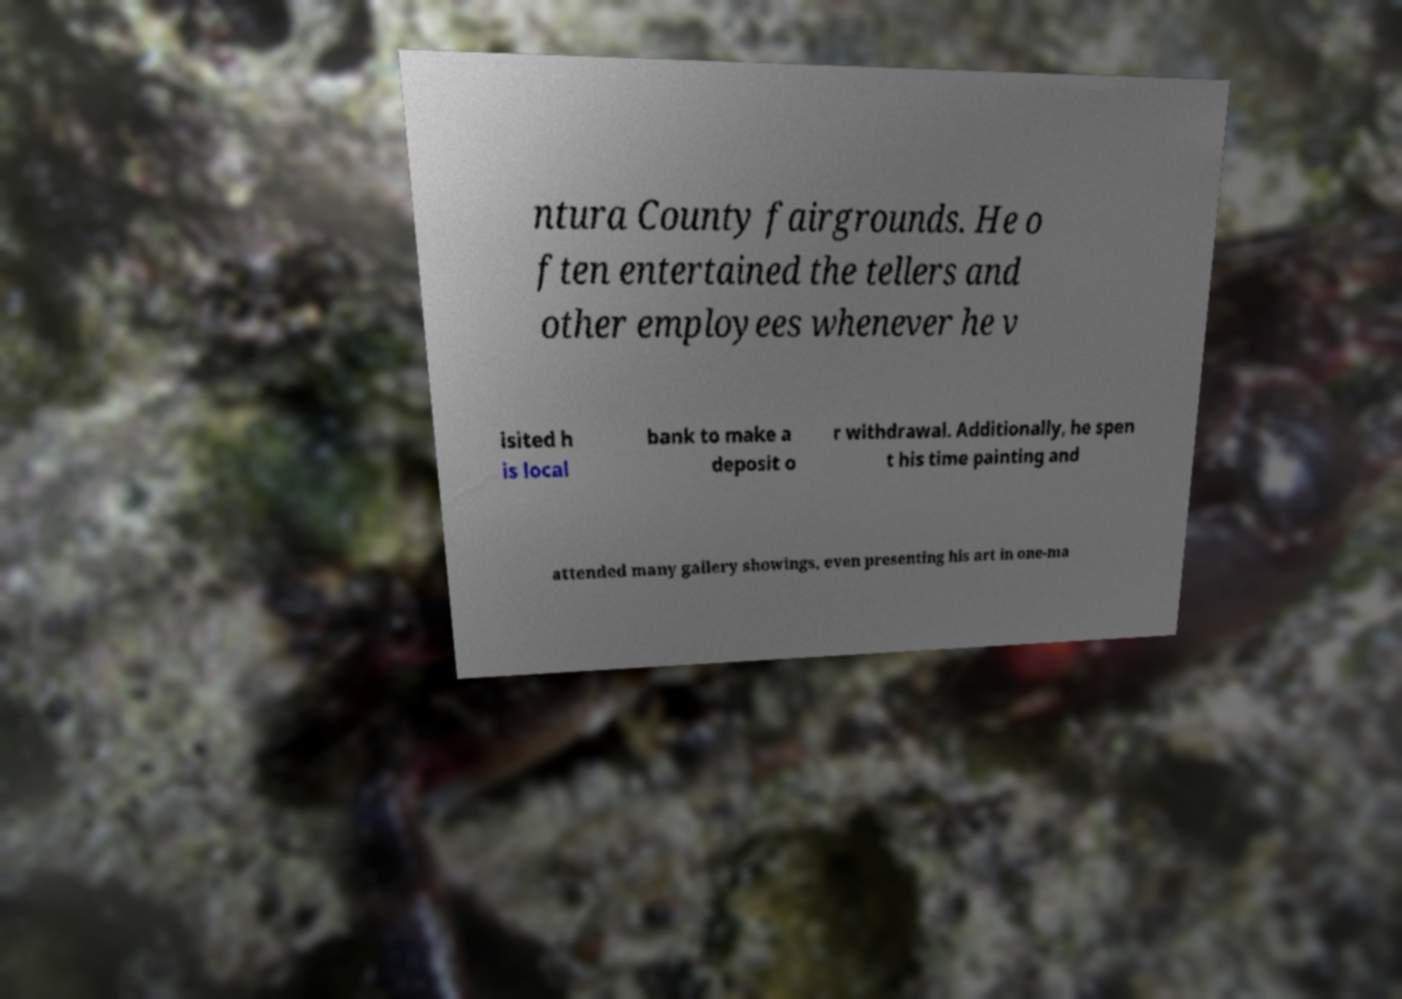Can you read and provide the text displayed in the image?This photo seems to have some interesting text. Can you extract and type it out for me? ntura County fairgrounds. He o ften entertained the tellers and other employees whenever he v isited h is local bank to make a deposit o r withdrawal. Additionally, he spen t his time painting and attended many gallery showings, even presenting his art in one-ma 